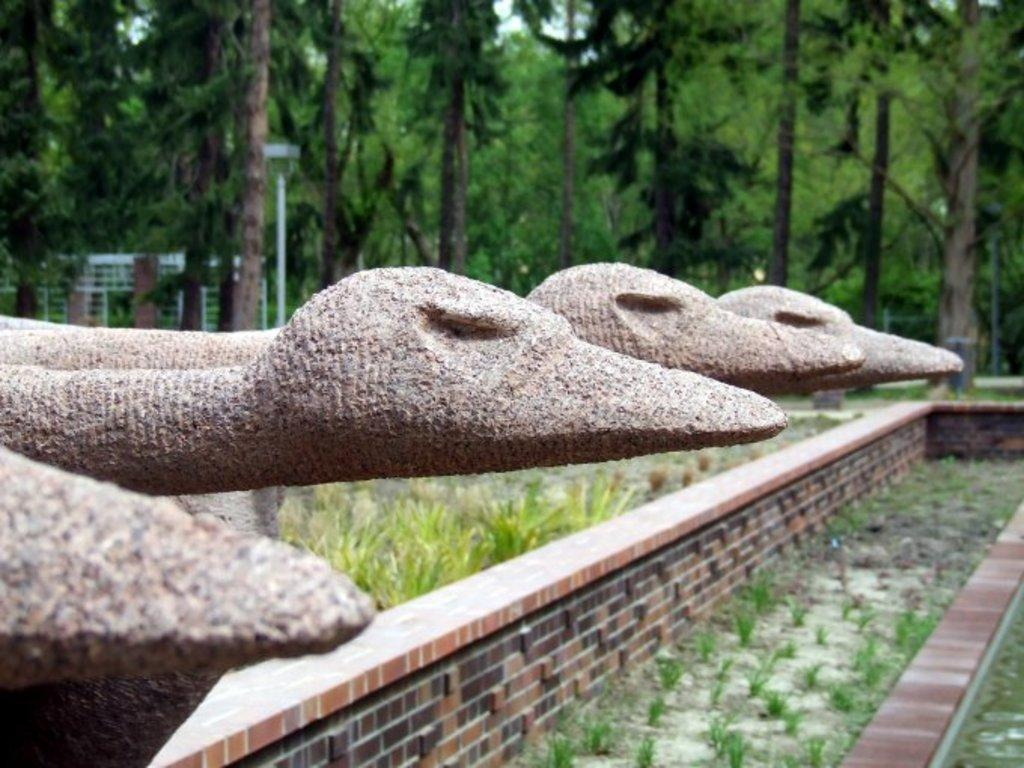What type of vegetation is present in the image? There are trees and plants in the image. What kind of lighting is visible in the image? There is a pole light in the image. What type of artwork is featured in the image? There is a stone carving in the image. What type of breakfast is being served on the steel plate in the image? There is no breakfast or steel plate present in the image. Can you see any worms crawling on the stone carving in the image? There are no worms visible in the image, as it features trees, plants, a pole light, and a stone carving. 